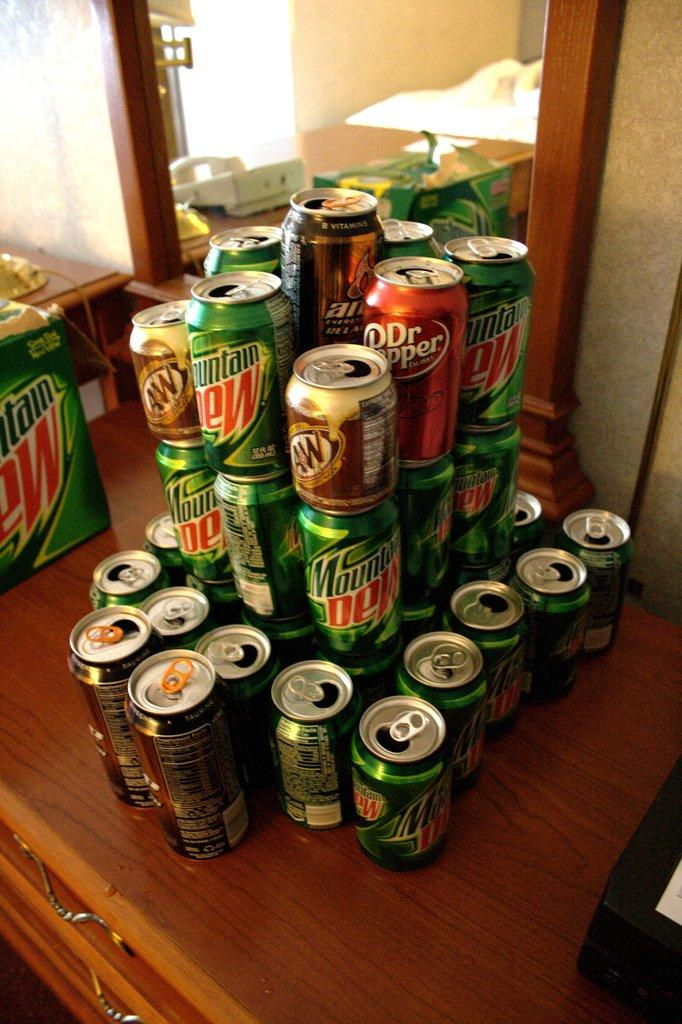Provide a one-sentence caption for the provided image. A stack of Dr. Pepper, Mountain Dew, and AW soda cans. 